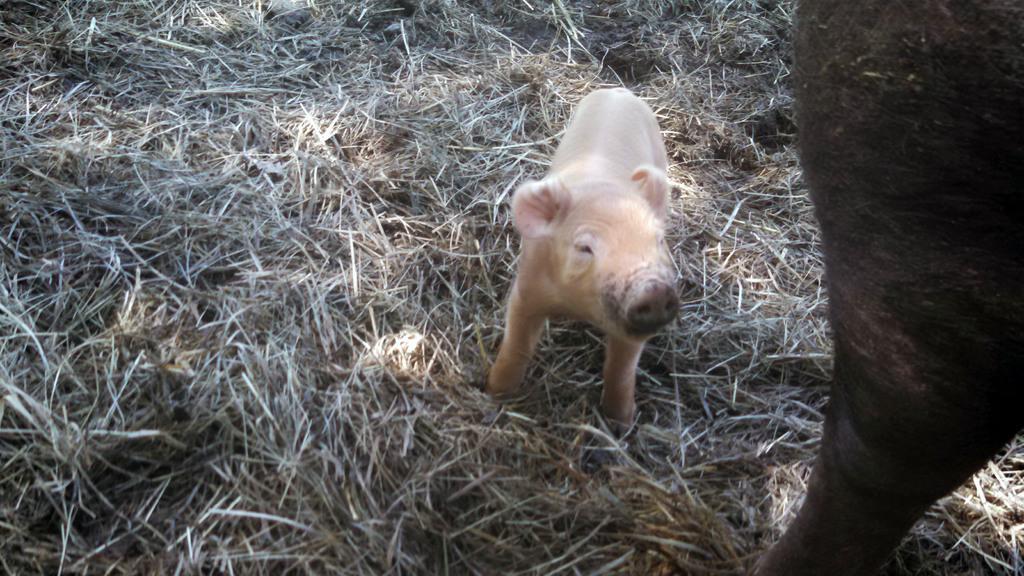Can you describe this image briefly? In this image there is a pig on the ground. On the ground there is dry grass. On the right side there is a leg of an animal. 